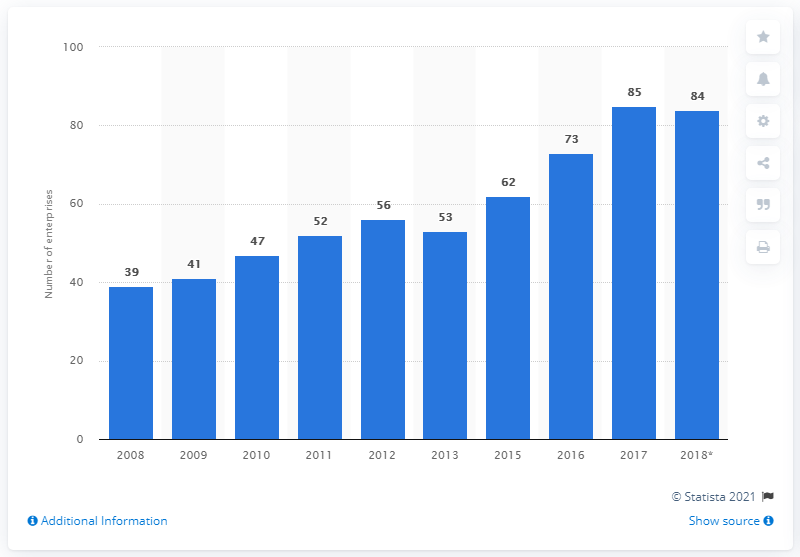Outline some significant characteristics in this image. In 2018, there were 84 enterprises in Sweden's manufacturing sector. 